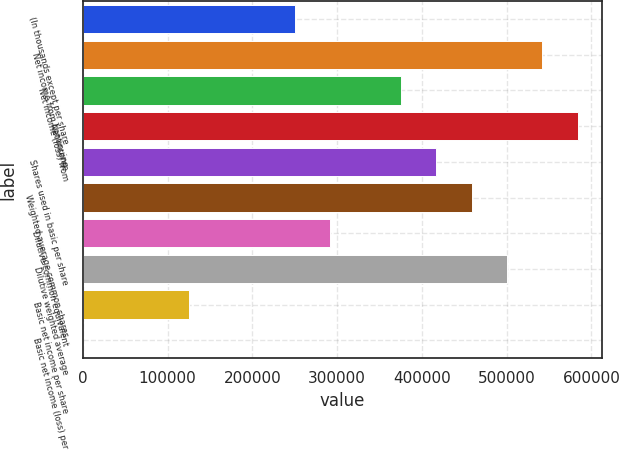Convert chart. <chart><loc_0><loc_0><loc_500><loc_500><bar_chart><fcel>(In thousands except per share<fcel>Net income from continuing<fcel>Net income (loss) from<fcel>Net income<fcel>Shares used in basic per share<fcel>Weighted average common shares<fcel>Dilutive common equivalent<fcel>Dilutive weighted average<fcel>Basic net income per share<fcel>Basic net income (loss) per<nl><fcel>250178<fcel>542052<fcel>375267<fcel>583748<fcel>416963<fcel>458659<fcel>291874<fcel>500356<fcel>125089<fcel>0.1<nl></chart> 